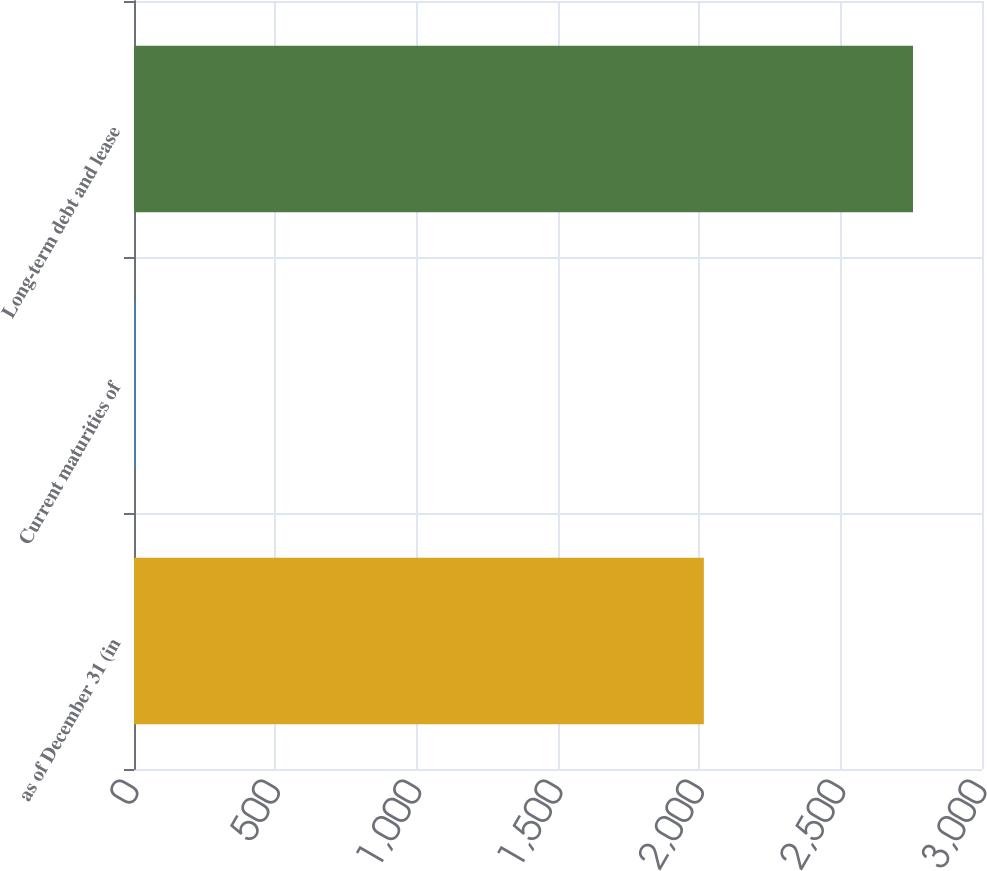Convert chart. <chart><loc_0><loc_0><loc_500><loc_500><bar_chart><fcel>as of December 31 (in<fcel>Current maturities of<fcel>Long-term debt and lease<nl><fcel>2016<fcel>3<fcel>2756<nl></chart> 